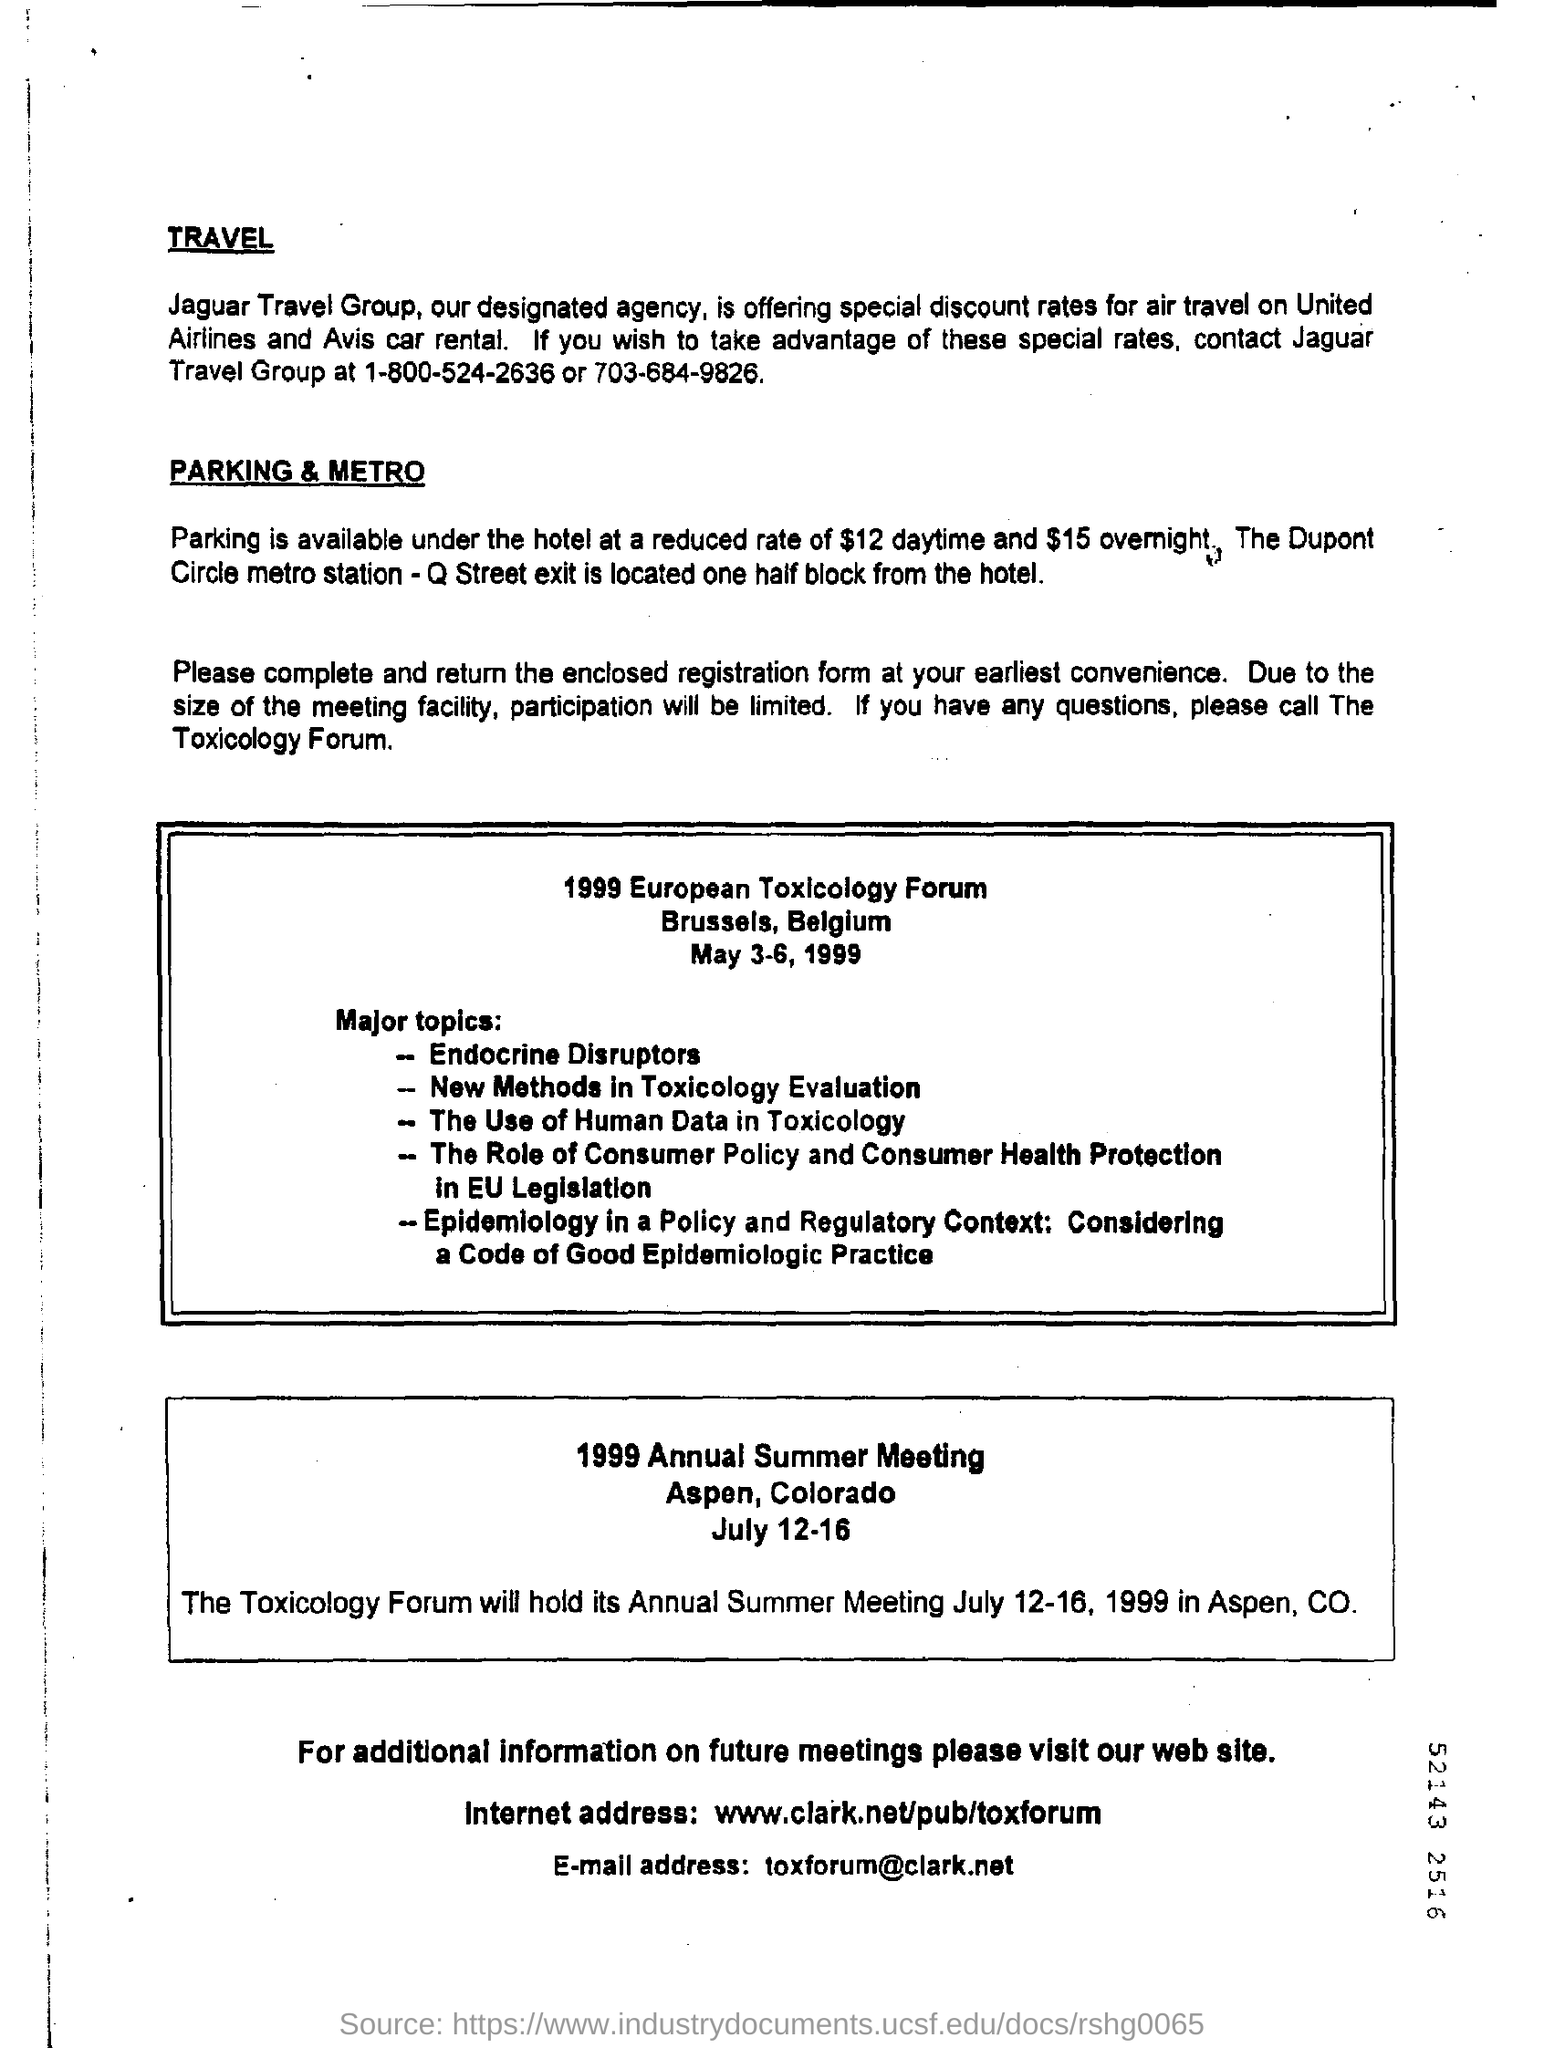Point out several critical features in this image. The cost of parking at the hotel during the daytime is $12. The e-mail address mentioned on the page is [toxforum@clark.net](mailto:toxforum@clark.net). The Jaguar Travel Group is the name of a travel group. The contact number for Jaguar Travel Group is 1-800-524-2636 or 703-684-9826. The cost of overnight parking at the hotel is $15. 